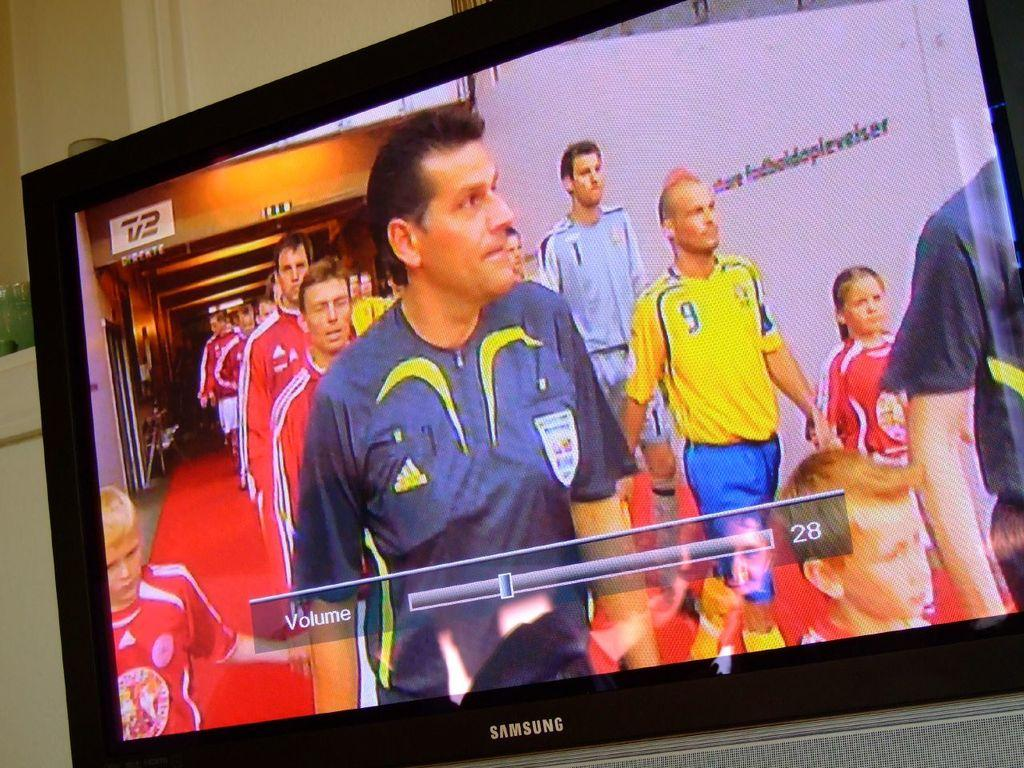What is the main object in the image? There is a screen in the image. What can be seen on the screen? People, boards, and a banner are visible on the screen. What is the purpose of the banner on the screen? The purpose of the banner on the screen is not clear from the image, but it may be for promotional or informational purposes. What can be seen in the background of the image? There are objects and a wall in the background of the image. What type of force is being applied to the top of the screen in the image? There is no force being applied to the top of the screen in the image; it is a static image of a screen with people, boards, and a banner. What type of learning is taking place in the image? There is no indication of learning taking place in the image; it simply shows a screen with people, boards, and a banner. 